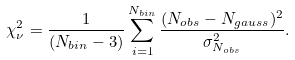Convert formula to latex. <formula><loc_0><loc_0><loc_500><loc_500>\chi ^ { 2 } _ { \nu } = \frac { 1 } { ( N _ { b i n } - 3 ) } \sum _ { i = 1 } ^ { N _ { b i n } } \frac { ( N _ { o b s } - N _ { g a u s s } ) ^ { 2 } } { \sigma _ { N _ { o b s } } ^ { 2 } } .</formula> 